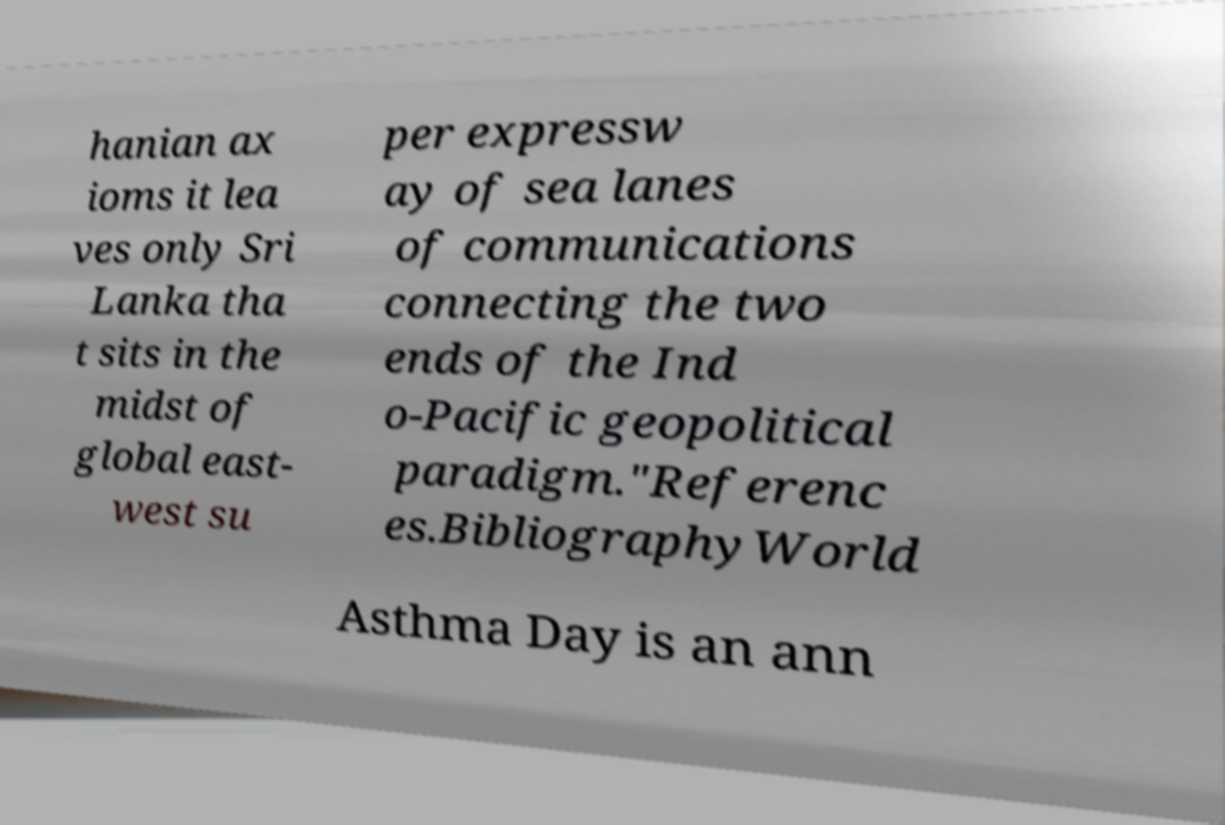There's text embedded in this image that I need extracted. Can you transcribe it verbatim? hanian ax ioms it lea ves only Sri Lanka tha t sits in the midst of global east- west su per expressw ay of sea lanes of communications connecting the two ends of the Ind o-Pacific geopolitical paradigm."Referenc es.BibliographyWorld Asthma Day is an ann 